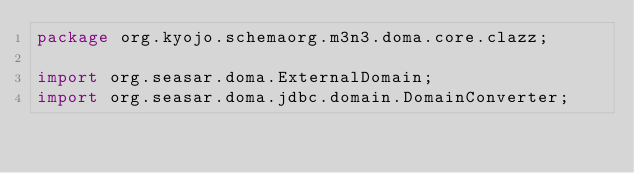<code> <loc_0><loc_0><loc_500><loc_500><_Java_>package org.kyojo.schemaorg.m3n3.doma.core.clazz;

import org.seasar.doma.ExternalDomain;
import org.seasar.doma.jdbc.domain.DomainConverter;
</code> 